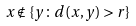Convert formula to latex. <formula><loc_0><loc_0><loc_500><loc_500>x \notin \{ y \colon d ( x , y ) > r \}</formula> 